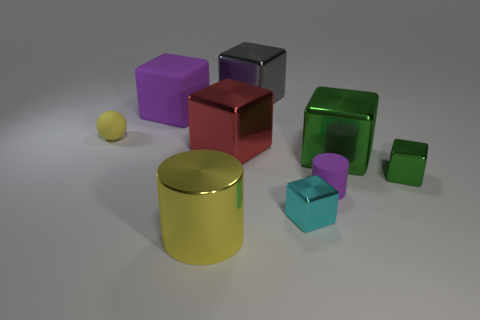The matte sphere that is the same color as the large cylinder is what size?
Keep it short and to the point. Small. The metallic object that is to the right of the big metal cylinder and in front of the small green shiny object has what shape?
Offer a very short reply. Cube. Are there the same number of green things that are on the left side of the yellow metallic thing and small metallic objects that are left of the cyan thing?
Your answer should be very brief. Yes. How many objects are large red shiny cubes or tiny cylinders?
Your response must be concise. 2. What is the color of the metal cylinder that is the same size as the red object?
Your response must be concise. Yellow. What number of objects are big blocks that are on the right side of the tiny cylinder or green blocks behind the small green object?
Ensure brevity in your answer.  1. Are there the same number of small green things that are behind the purple rubber cube and gray things?
Offer a terse response. No. Do the purple object behind the yellow matte object and the yellow thing that is behind the metal cylinder have the same size?
Keep it short and to the point. No. What number of other things are the same size as the yellow metal cylinder?
Keep it short and to the point. 4. Are there any big yellow objects that are to the right of the object that is behind the purple object that is behind the yellow sphere?
Make the answer very short. No. 